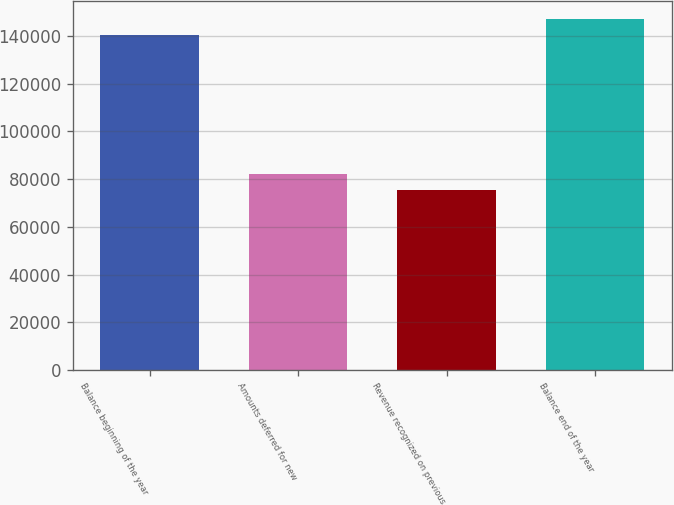Convert chart. <chart><loc_0><loc_0><loc_500><loc_500><bar_chart><fcel>Balance beginning of the year<fcel>Amounts deferred for new<fcel>Revenue recognized on previous<fcel>Balance end of the year<nl><fcel>140603<fcel>82150.7<fcel>75603<fcel>147151<nl></chart> 